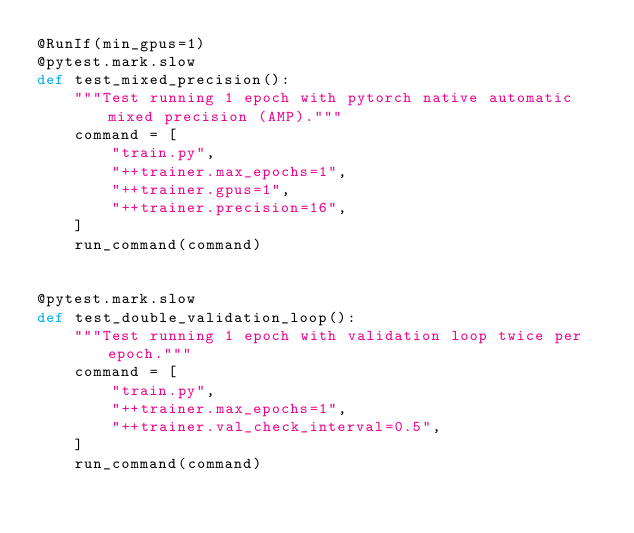<code> <loc_0><loc_0><loc_500><loc_500><_Python_>@RunIf(min_gpus=1)
@pytest.mark.slow
def test_mixed_precision():
    """Test running 1 epoch with pytorch native automatic mixed precision (AMP)."""
    command = [
        "train.py",
        "++trainer.max_epochs=1",
        "++trainer.gpus=1",
        "++trainer.precision=16",
    ]
    run_command(command)


@pytest.mark.slow
def test_double_validation_loop():
    """Test running 1 epoch with validation loop twice per epoch."""
    command = [
        "train.py",
        "++trainer.max_epochs=1",
        "++trainer.val_check_interval=0.5",
    ]
    run_command(command)
</code> 